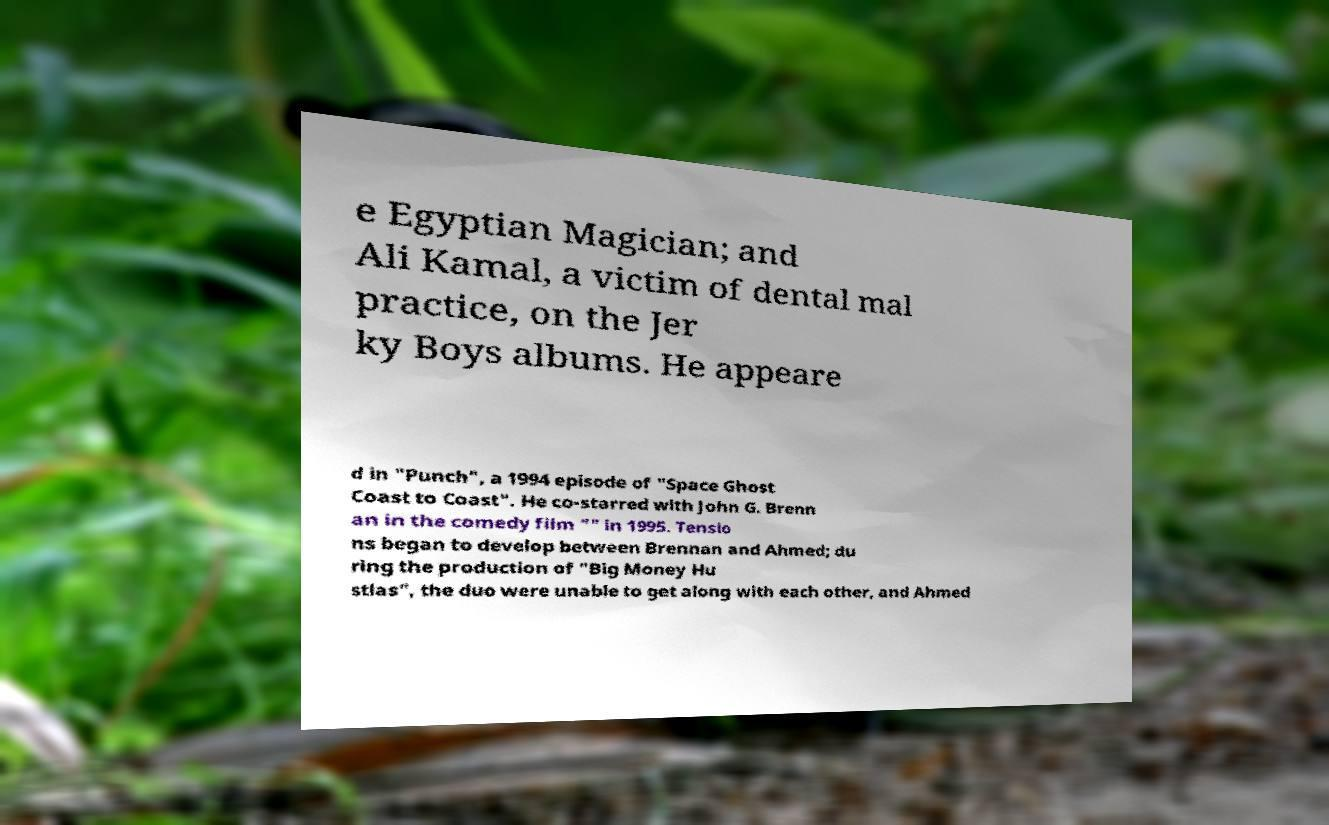Please read and relay the text visible in this image. What does it say? e Egyptian Magician; and Ali Kamal, a victim of dental mal practice, on the Jer ky Boys albums. He appeare d in "Punch", a 1994 episode of "Space Ghost Coast to Coast". He co-starred with John G. Brenn an in the comedy film "" in 1995. Tensio ns began to develop between Brennan and Ahmed; du ring the production of "Big Money Hu stlas", the duo were unable to get along with each other, and Ahmed 